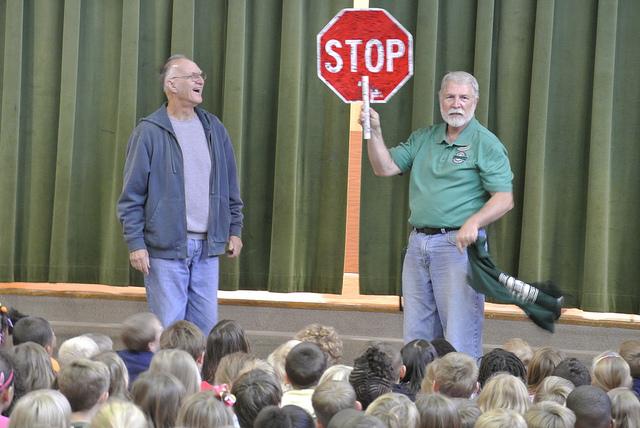Is one of the men crying?
Keep it brief. No. Who has a flower in their hair?
Write a very short answer. No one. What is the sign say?
Short answer required. Stop. 